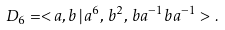<formula> <loc_0><loc_0><loc_500><loc_500>D _ { 6 } = < a , b \, | \, a ^ { 6 } , \, b ^ { 2 } , \, b a ^ { - 1 } b a ^ { - 1 } > \, .</formula> 